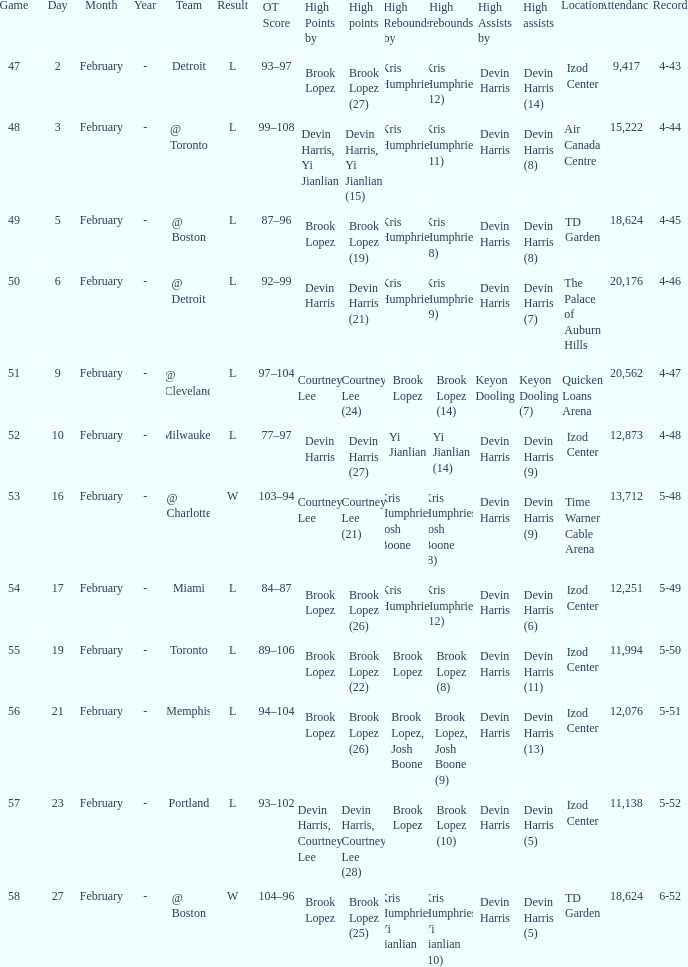What was the record in the game against Memphis? 5-51. 